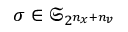Convert formula to latex. <formula><loc_0><loc_0><loc_500><loc_500>\sigma \in \mathfrak { S } _ { 2 ^ { n _ { x } + n _ { v } } }</formula> 